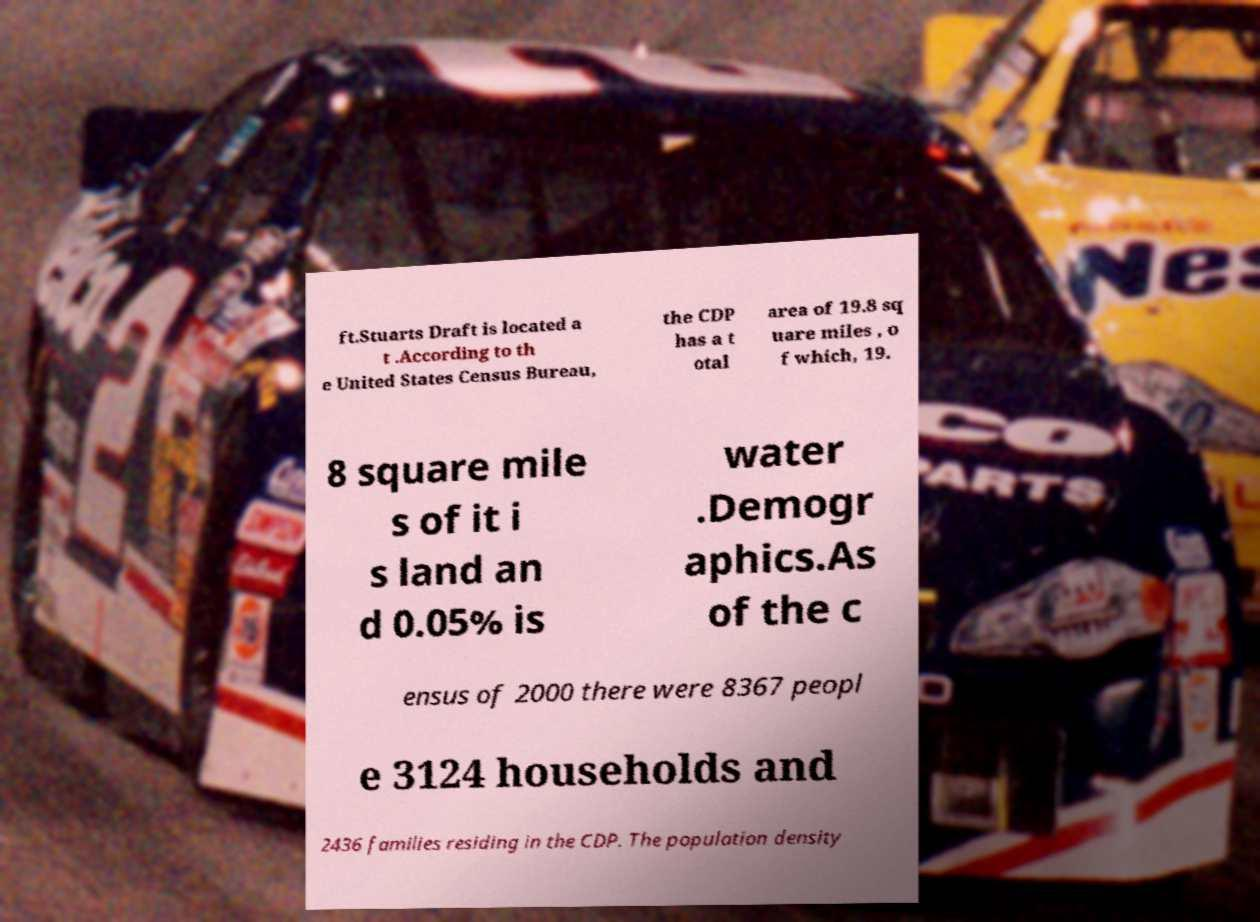What messages or text are displayed in this image? I need them in a readable, typed format. ft.Stuarts Draft is located a t .According to th e United States Census Bureau, the CDP has a t otal area of 19.8 sq uare miles , o f which, 19. 8 square mile s of it i s land an d 0.05% is water .Demogr aphics.As of the c ensus of 2000 there were 8367 peopl e 3124 households and 2436 families residing in the CDP. The population density 